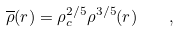Convert formula to latex. <formula><loc_0><loc_0><loc_500><loc_500>\overline { \rho } ( r ) = \rho _ { c } ^ { 2 / 5 } \rho ^ { 3 / 5 } ( r ) \quad ,</formula> 